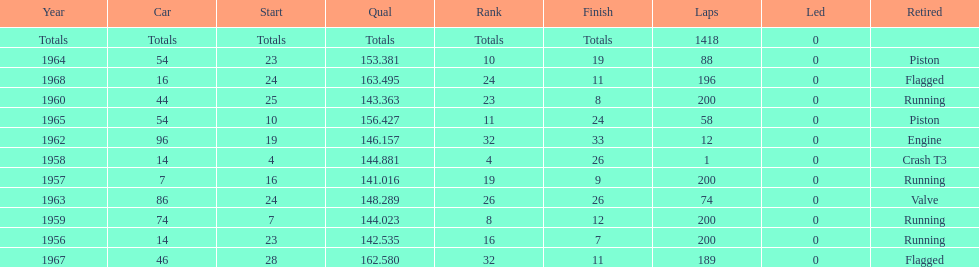What was the last year that it finished the race? 1968. 